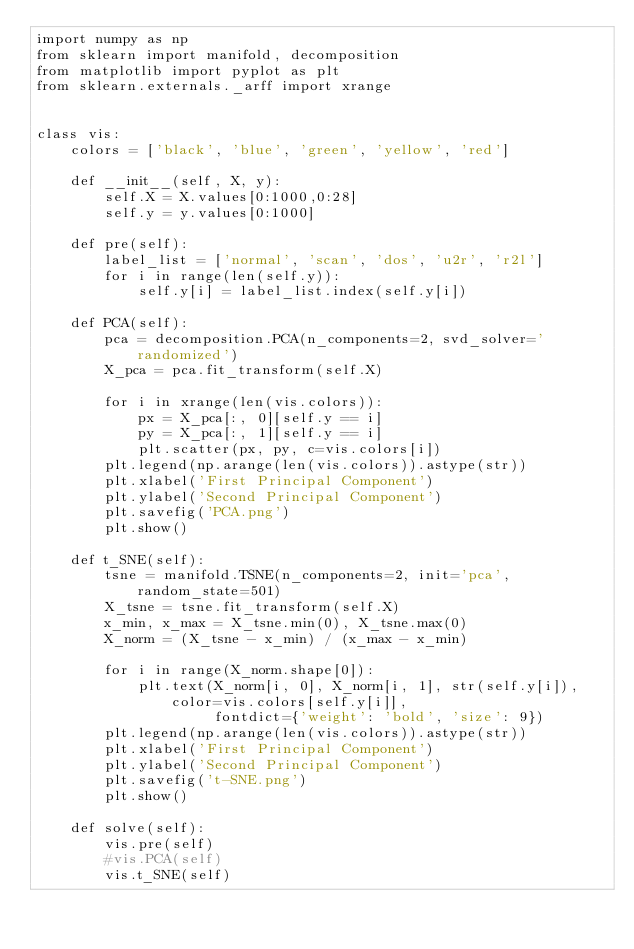Convert code to text. <code><loc_0><loc_0><loc_500><loc_500><_Python_>import numpy as np
from sklearn import manifold, decomposition
from matplotlib import pyplot as plt
from sklearn.externals._arff import xrange


class vis:
    colors = ['black', 'blue', 'green', 'yellow', 'red']

    def __init__(self, X, y):
        self.X = X.values[0:1000,0:28]
        self.y = y.values[0:1000]

    def pre(self):
        label_list = ['normal', 'scan', 'dos', 'u2r', 'r2l']
        for i in range(len(self.y)):
            self.y[i] = label_list.index(self.y[i])

    def PCA(self):
        pca = decomposition.PCA(n_components=2, svd_solver='randomized')
        X_pca = pca.fit_transform(self.X)

        for i in xrange(len(vis.colors)):
            px = X_pca[:, 0][self.y == i]
            py = X_pca[:, 1][self.y == i]
            plt.scatter(px, py, c=vis.colors[i])
        plt.legend(np.arange(len(vis.colors)).astype(str))
        plt.xlabel('First Principal Component')
        plt.ylabel('Second Principal Component')
        plt.savefig('PCA.png')
        plt.show()

    def t_SNE(self):
        tsne = manifold.TSNE(n_components=2, init='pca', random_state=501)
        X_tsne = tsne.fit_transform(self.X)
        x_min, x_max = X_tsne.min(0), X_tsne.max(0)
        X_norm = (X_tsne - x_min) / (x_max - x_min)

        for i in range(X_norm.shape[0]):
            plt.text(X_norm[i, 0], X_norm[i, 1], str(self.y[i]), color=vis.colors[self.y[i]],
                     fontdict={'weight': 'bold', 'size': 9})
        plt.legend(np.arange(len(vis.colors)).astype(str))
        plt.xlabel('First Principal Component')
        plt.ylabel('Second Principal Component')
        plt.savefig('t-SNE.png')
        plt.show()

    def solve(self):
        vis.pre(self)
        #vis.PCA(self)
        vis.t_SNE(self)

</code> 